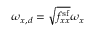Convert formula to latex. <formula><loc_0><loc_0><loc_500><loc_500>\omega _ { x , d } = \sqrt { f _ { x x } ^ { s f } } \omega _ { x }</formula> 